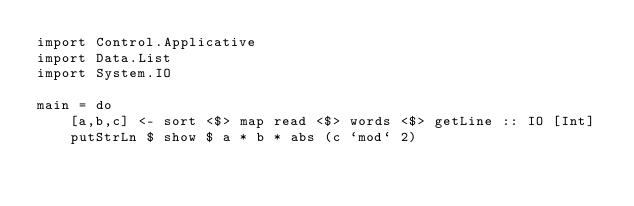Convert code to text. <code><loc_0><loc_0><loc_500><loc_500><_Haskell_>import Control.Applicative
import Data.List
import System.IO

main = do
    [a,b,c] <- sort <$> map read <$> words <$> getLine :: IO [Int]
    putStrLn $ show $ a * b * abs (c `mod` 2)
</code> 